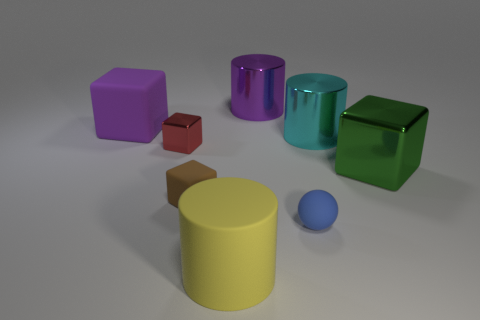Are any small blue things visible?
Ensure brevity in your answer.  Yes. How big is the shiny cube on the left side of the small matte object right of the small rubber object that is to the left of the yellow rubber thing?
Offer a very short reply. Small. How many other objects are there of the same size as the cyan shiny object?
Offer a very short reply. 4. What size is the block that is in front of the green object?
Your answer should be compact. Small. Is there anything else that is the same color as the matte ball?
Give a very brief answer. No. Are the cube that is right of the big yellow object and the large cyan cylinder made of the same material?
Your answer should be compact. Yes. How many things are both to the left of the tiny blue rubber ball and in front of the tiny brown matte object?
Provide a succinct answer. 1. There is a matte object that is left of the rubber block that is in front of the big green metal object; how big is it?
Provide a short and direct response. Large. Is there any other thing that has the same material as the green thing?
Your answer should be very brief. Yes. Are there more small cyan rubber cylinders than yellow things?
Make the answer very short. No. 